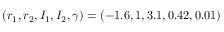<formula> <loc_0><loc_0><loc_500><loc_500>( r _ { 1 } , r _ { 2 } , I _ { 1 } , I _ { 2 } , \gamma ) = ( - 1 . 6 , 1 , 3 . 1 , 0 . 4 2 , 0 . 0 1 )</formula> 